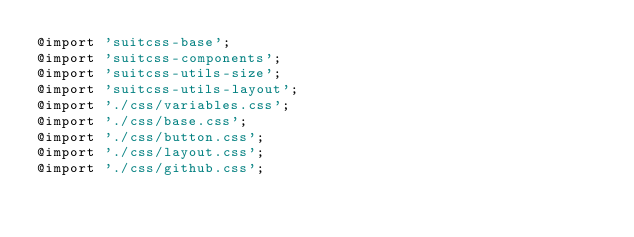<code> <loc_0><loc_0><loc_500><loc_500><_CSS_>@import 'suitcss-base';
@import 'suitcss-components';
@import 'suitcss-utils-size';
@import 'suitcss-utils-layout';
@import './css/variables.css';
@import './css/base.css';
@import './css/button.css';
@import './css/layout.css';
@import './css/github.css';
</code> 